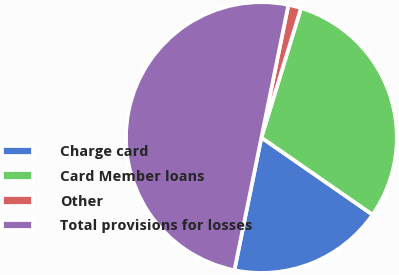Convert chart. <chart><loc_0><loc_0><loc_500><loc_500><pie_chart><fcel>Charge card<fcel>Card Member loans<fcel>Other<fcel>Total provisions for losses<nl><fcel>18.54%<fcel>29.93%<fcel>1.53%<fcel>50.0%<nl></chart> 